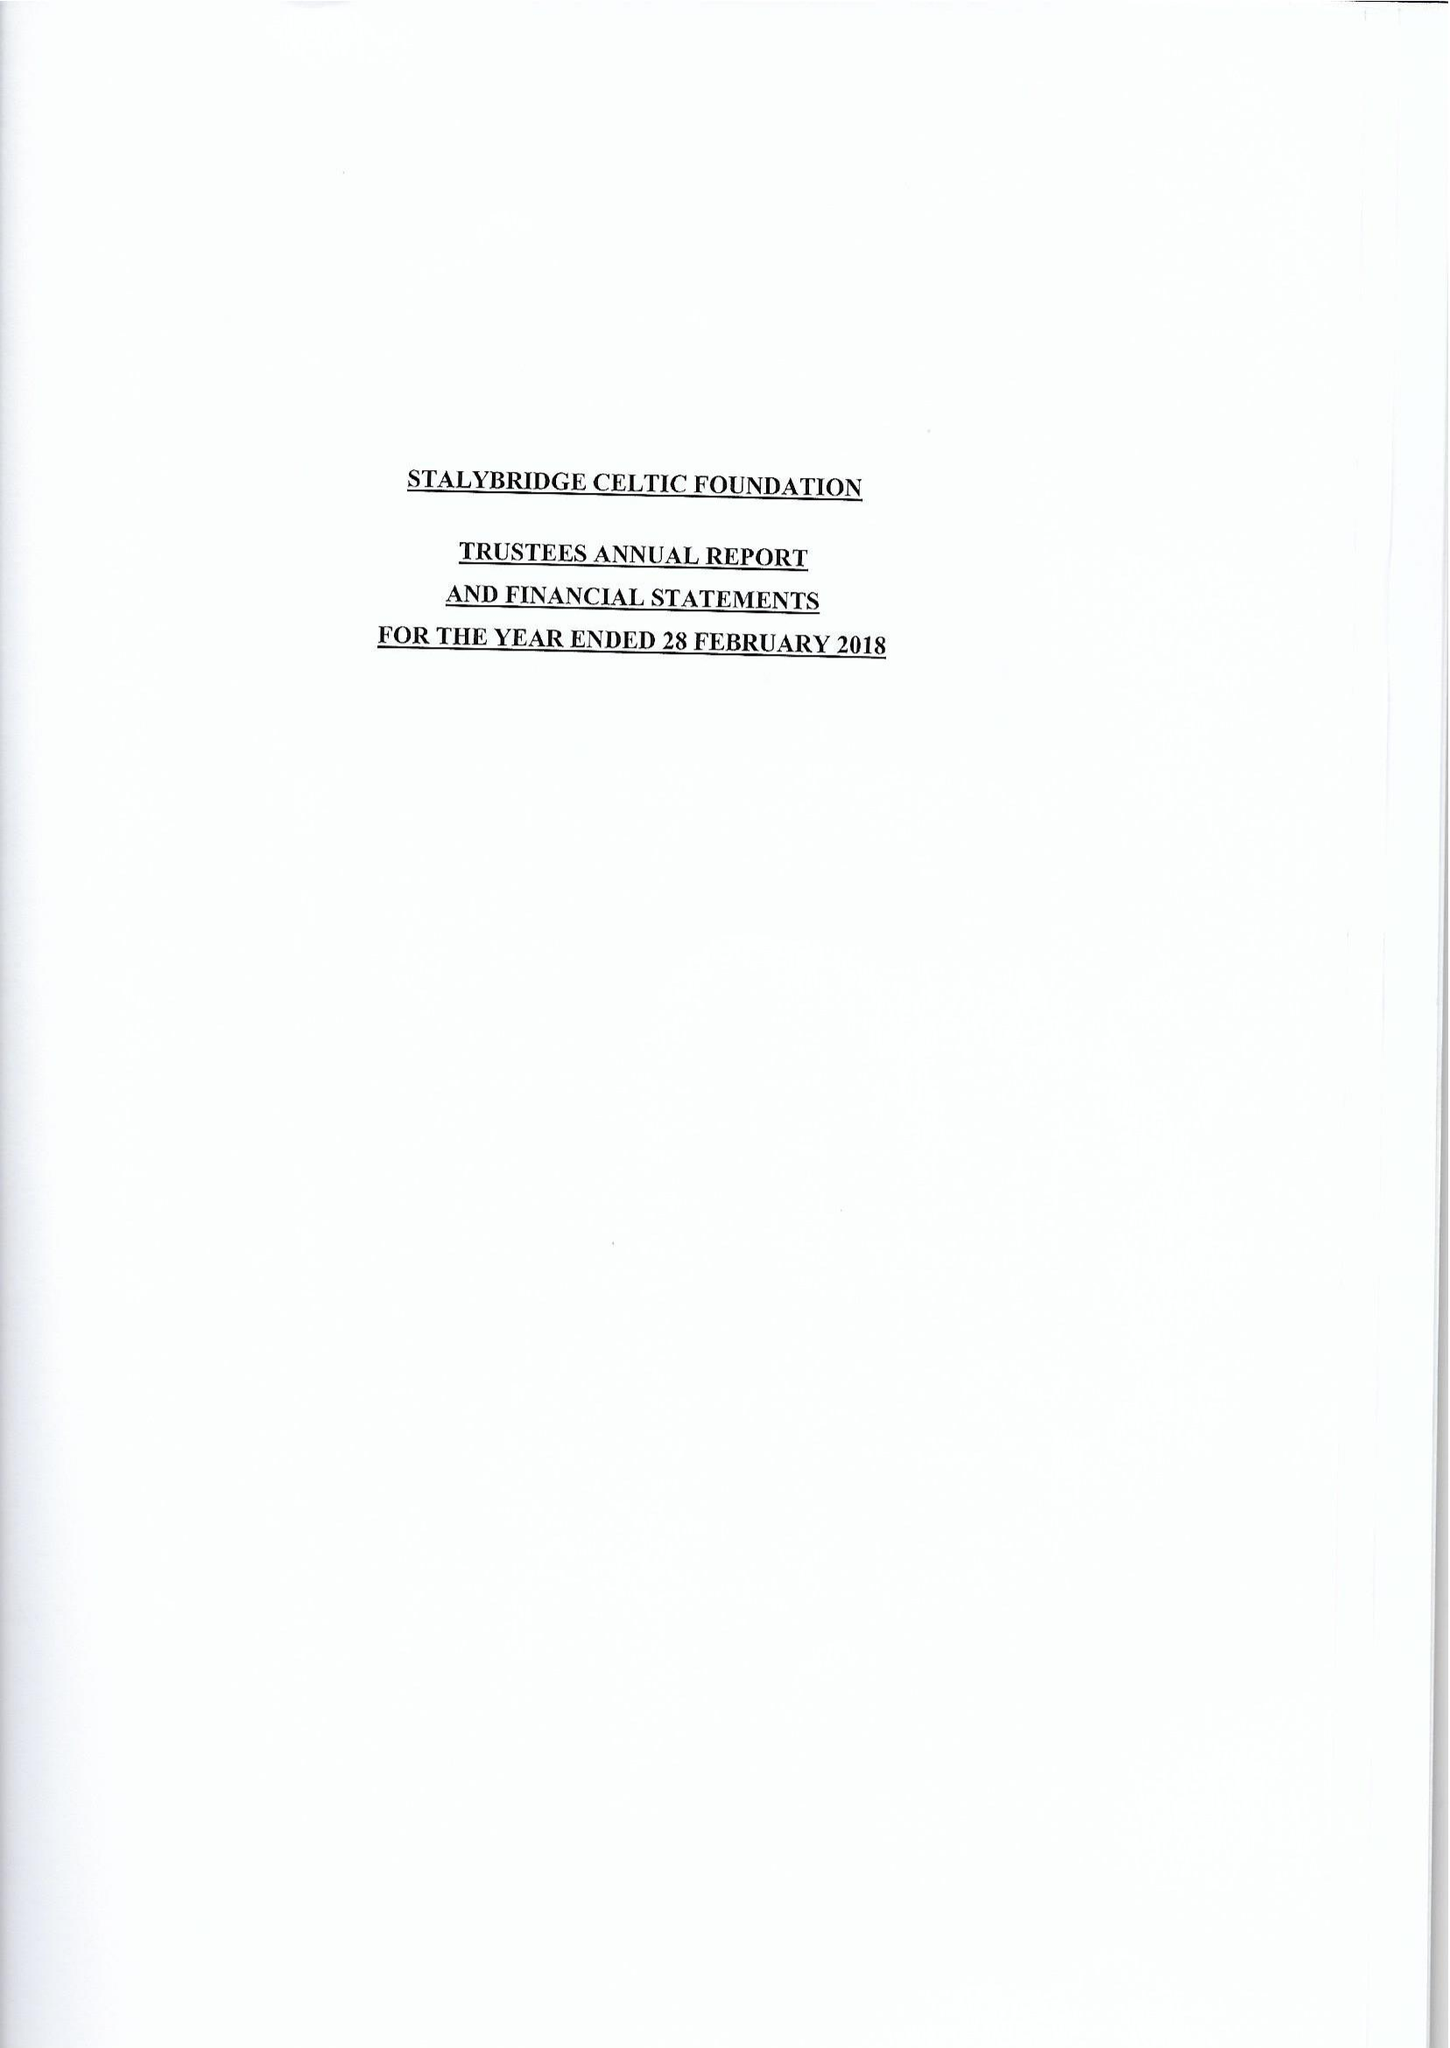What is the value for the income_annually_in_british_pounds?
Answer the question using a single word or phrase. 34539.00 